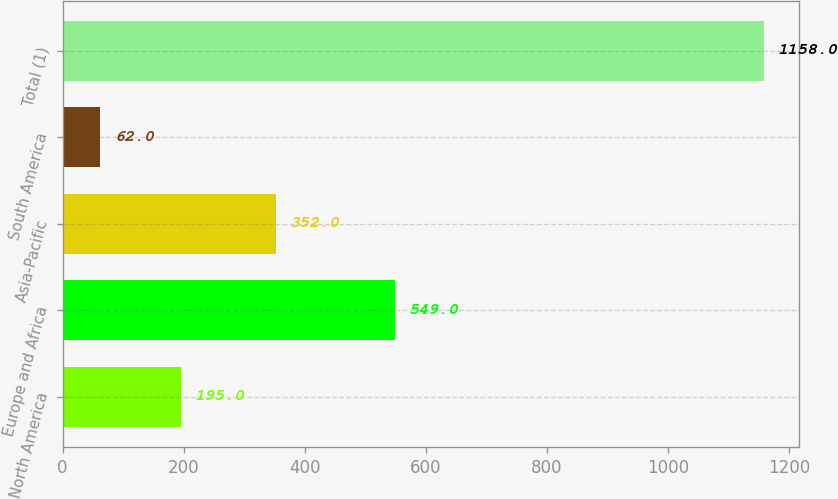<chart> <loc_0><loc_0><loc_500><loc_500><bar_chart><fcel>North America<fcel>Europe and Africa<fcel>Asia-Pacific<fcel>South America<fcel>Total (1)<nl><fcel>195<fcel>549<fcel>352<fcel>62<fcel>1158<nl></chart> 